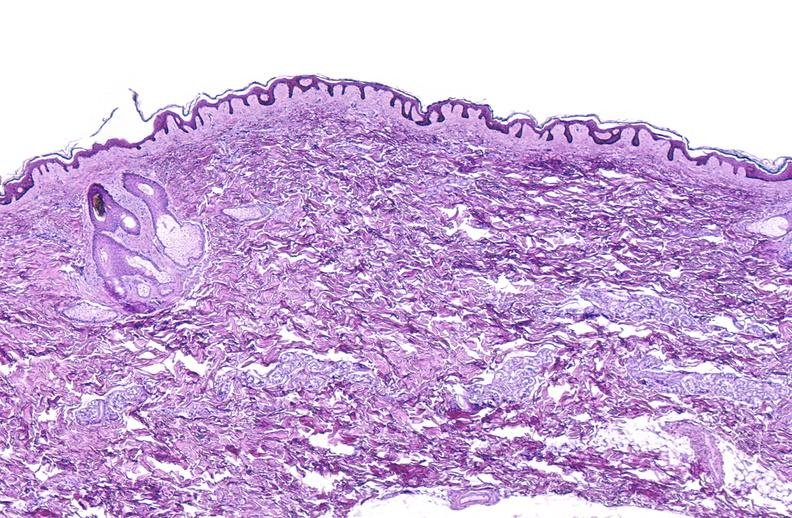does this image show scleroderma?
Answer the question using a single word or phrase. Yes 